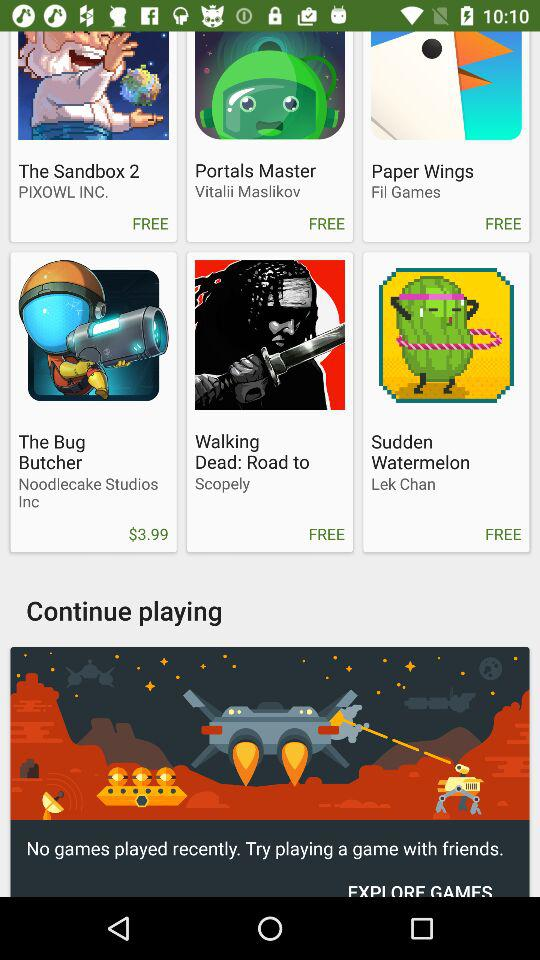How many games are not free?
Answer the question using a single word or phrase. 1 